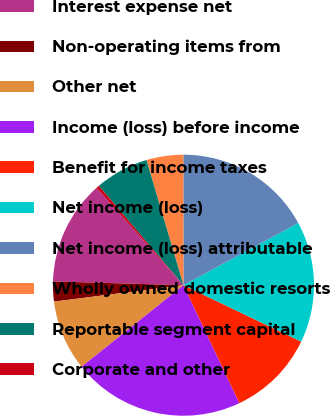Convert chart to OTSL. <chart><loc_0><loc_0><loc_500><loc_500><pie_chart><fcel>Interest expense net<fcel>Non-operating items from<fcel>Other net<fcel>Income (loss) before income<fcel>Benefit for income taxes<fcel>Net income (loss)<fcel>Net income (loss) attributable<fcel>Wholly owned domestic resorts<fcel>Reportable segment capital<fcel>Corporate and other<nl><fcel>12.93%<fcel>2.47%<fcel>8.74%<fcel>21.3%<fcel>10.84%<fcel>15.02%<fcel>17.11%<fcel>4.56%<fcel>6.65%<fcel>0.38%<nl></chart> 